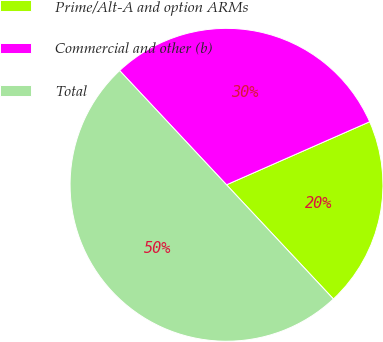Convert chart. <chart><loc_0><loc_0><loc_500><loc_500><pie_chart><fcel>Prime/Alt-A and option ARMs<fcel>Commercial and other (b)<fcel>Total<nl><fcel>19.63%<fcel>30.37%<fcel>50.0%<nl></chart> 